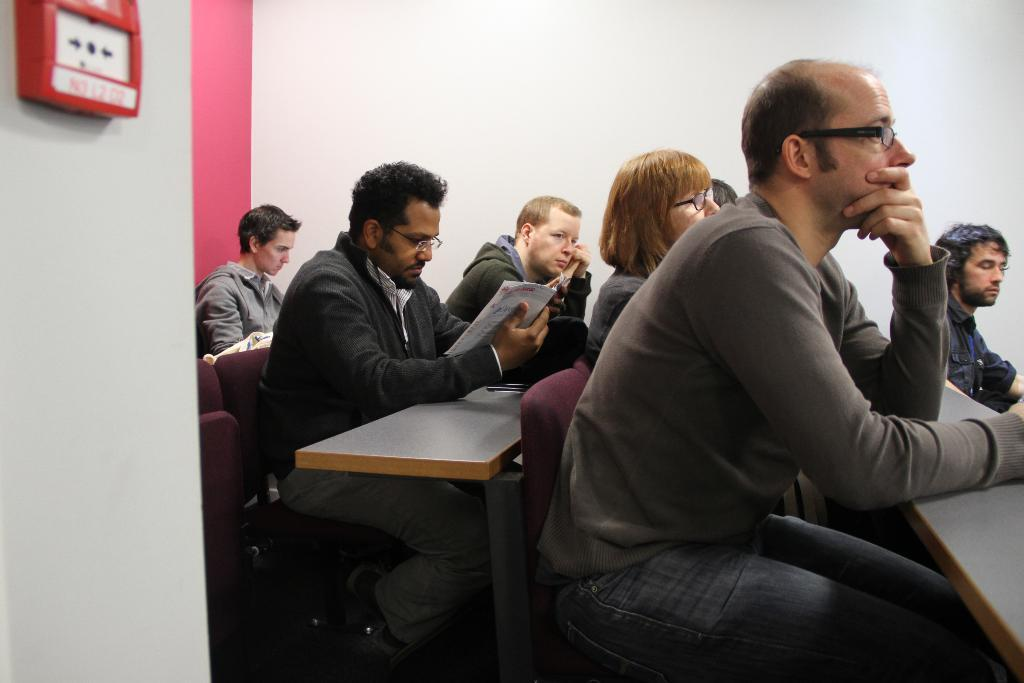Where was the image taken? The image was taken in a room. What furniture is present in the room? The room contains tables and chairs. What are the people in the room doing? There are people sitting in the room. Where is the fire alarm located in the room? The fire alarm is on the left side of the room, attached to the wall. How many mice can be seen running on the roof in the image? There are no mice or roof visible in the image; it is taken in a room with tables, chairs, and people sitting. 